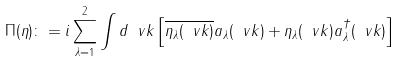<formula> <loc_0><loc_0><loc_500><loc_500>\Pi ( \eta ) \colon = i \sum _ { \lambda = 1 } ^ { 2 } \int d \ v k \left [ \overline { \eta _ { \lambda } ( \ v k ) } a _ { \lambda } ( \ v k ) + \eta _ { \lambda } ( \ v k ) a _ { \lambda } ^ { \dagger } ( \ v k ) \right ]</formula> 